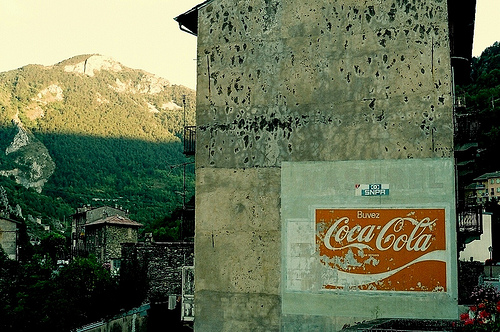<image>
Is the sign under the mountain? Yes. The sign is positioned underneath the mountain, with the mountain above it in the vertical space. 